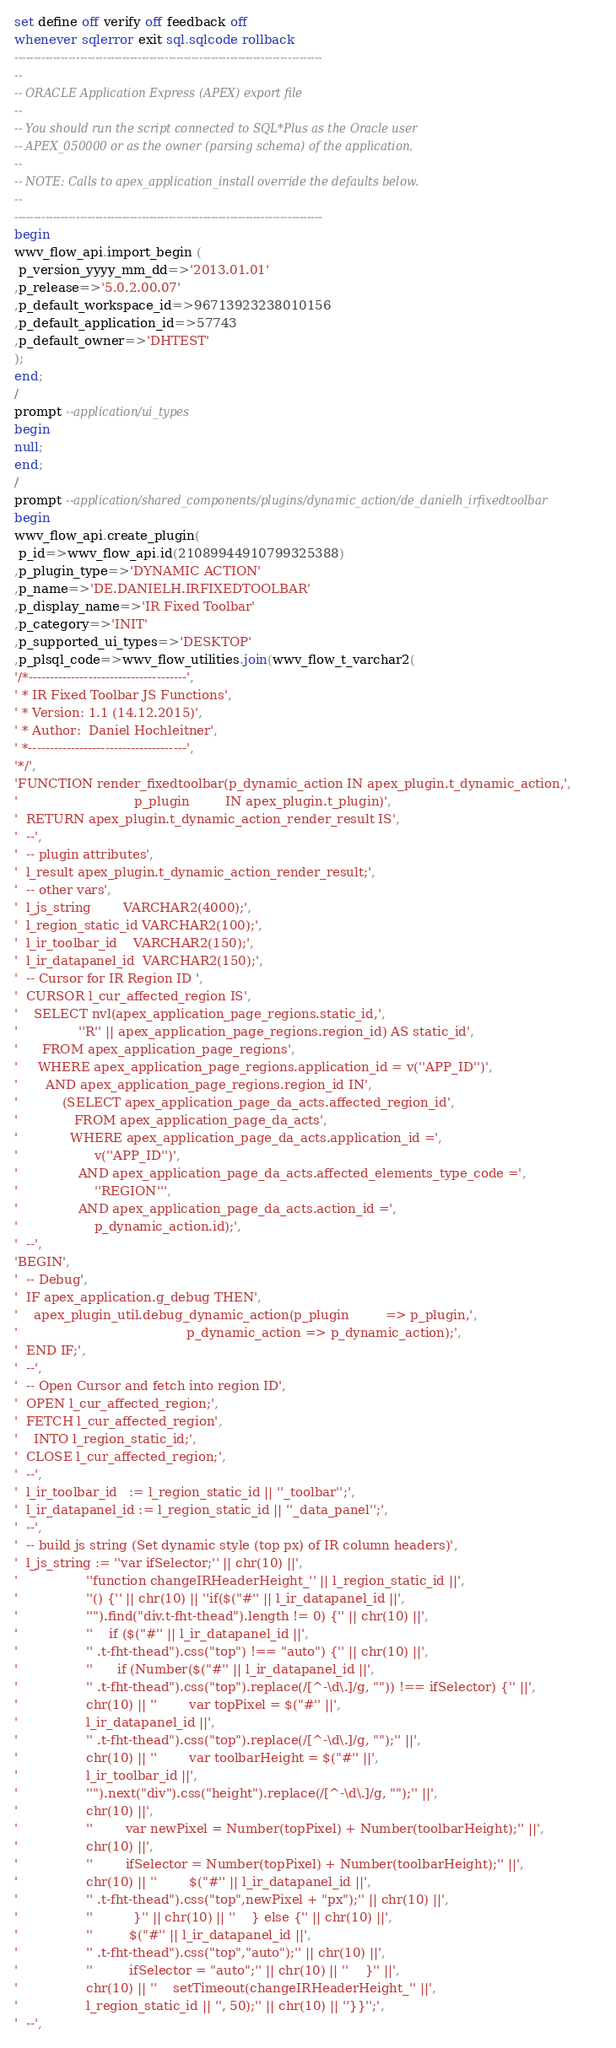<code> <loc_0><loc_0><loc_500><loc_500><_SQL_>set define off verify off feedback off
whenever sqlerror exit sql.sqlcode rollback
--------------------------------------------------------------------------------
--
-- ORACLE Application Express (APEX) export file
--
-- You should run the script connected to SQL*Plus as the Oracle user
-- APEX_050000 or as the owner (parsing schema) of the application.
--
-- NOTE: Calls to apex_application_install override the defaults below.
--
--------------------------------------------------------------------------------
begin
wwv_flow_api.import_begin (
 p_version_yyyy_mm_dd=>'2013.01.01'
,p_release=>'5.0.2.00.07'
,p_default_workspace_id=>96713923238010156
,p_default_application_id=>57743
,p_default_owner=>'DHTEST'
);
end;
/
prompt --application/ui_types
begin
null;
end;
/
prompt --application/shared_components/plugins/dynamic_action/de_danielh_irfixedtoolbar
begin
wwv_flow_api.create_plugin(
 p_id=>wwv_flow_api.id(21089944910799325388)
,p_plugin_type=>'DYNAMIC ACTION'
,p_name=>'DE.DANIELH.IRFIXEDTOOLBAR'
,p_display_name=>'IR Fixed Toolbar'
,p_category=>'INIT'
,p_supported_ui_types=>'DESKTOP'
,p_plsql_code=>wwv_flow_utilities.join(wwv_flow_t_varchar2(
'/*-------------------------------------',
' * IR Fixed Toolbar JS Functions',
' * Version: 1.1 (14.12.2015)',
' * Author:  Daniel Hochleitner',
' *-------------------------------------',
'*/',
'FUNCTION render_fixedtoolbar(p_dynamic_action IN apex_plugin.t_dynamic_action,',
'                             p_plugin         IN apex_plugin.t_plugin)',
'  RETURN apex_plugin.t_dynamic_action_render_result IS',
'  --',
'  -- plugin attributes',
'  l_result apex_plugin.t_dynamic_action_render_result;',
'  -- other vars',
'  l_js_string        VARCHAR2(4000);',
'  l_region_static_id VARCHAR2(100);',
'  l_ir_toolbar_id    VARCHAR2(150);',
'  l_ir_datapanel_id  VARCHAR2(150);',
'  -- Cursor for IR Region ID ',
'  CURSOR l_cur_affected_region IS',
'    SELECT nvl(apex_application_page_regions.static_id,',
'               ''R'' || apex_application_page_regions.region_id) AS static_id',
'      FROM apex_application_page_regions',
'     WHERE apex_application_page_regions.application_id = v(''APP_ID'')',
'       AND apex_application_page_regions.region_id IN',
'           (SELECT apex_application_page_da_acts.affected_region_id',
'              FROM apex_application_page_da_acts',
'             WHERE apex_application_page_da_acts.application_id =',
'                   v(''APP_ID'')',
'               AND apex_application_page_da_acts.affected_elements_type_code =',
'                   ''REGION''',
'               AND apex_application_page_da_acts.action_id =',
'                   p_dynamic_action.id);',
'  --',
'BEGIN',
'  -- Debug',
'  IF apex_application.g_debug THEN',
'    apex_plugin_util.debug_dynamic_action(p_plugin         => p_plugin,',
'                                          p_dynamic_action => p_dynamic_action);',
'  END IF;',
'  --',
'  -- Open Cursor and fetch into region ID',
'  OPEN l_cur_affected_region;',
'  FETCH l_cur_affected_region',
'    INTO l_region_static_id;',
'  CLOSE l_cur_affected_region;',
'  --',
'  l_ir_toolbar_id   := l_region_static_id || ''_toolbar'';',
'  l_ir_datapanel_id := l_region_static_id || ''_data_panel'';',
'  --',
'  -- build js string (Set dynamic style (top px) of IR column headers)',
'  l_js_string := ''var ifSelector;'' || chr(10) ||',
'                 ''function changeIRHeaderHeight_'' || l_region_static_id ||',
'                 ''() {'' || chr(10) || ''if($("#'' || l_ir_datapanel_id ||',
'                 ''").find("div.t-fht-thead").length != 0) {'' || chr(10) ||',
'                 ''    if ($("#'' || l_ir_datapanel_id ||',
'                 '' .t-fht-thead").css("top") !== "auto") {'' || chr(10) ||',
'                 ''      if (Number($("#'' || l_ir_datapanel_id ||',
'                 '' .t-fht-thead").css("top").replace(/[^-\d\.]/g, "")) !== ifSelector) {'' ||',
'                 chr(10) || ''        var topPixel = $("#'' ||',
'                 l_ir_datapanel_id ||',
'                 '' .t-fht-thead").css("top").replace(/[^-\d\.]/g, "");'' ||',
'                 chr(10) || ''        var toolbarHeight = $("#'' ||',
'                 l_ir_toolbar_id ||',
'                 ''").next("div").css("height").replace(/[^-\d\.]/g, "");'' ||',
'                 chr(10) ||',
'                 ''        var newPixel = Number(topPixel) + Number(toolbarHeight);'' ||',
'                 chr(10) ||',
'                 ''        ifSelector = Number(topPixel) + Number(toolbarHeight);'' ||',
'                 chr(10) || ''        $("#'' || l_ir_datapanel_id ||',
'                 '' .t-fht-thead").css("top",newPixel + "px");'' || chr(10) ||',
'                 ''          }'' || chr(10) || ''    } else {'' || chr(10) ||',
'                 ''         $("#'' || l_ir_datapanel_id ||',
'                 '' .t-fht-thead").css("top","auto");'' || chr(10) ||',
'                 ''         ifSelector = "auto";'' || chr(10) || ''    }'' ||',
'                 chr(10) || ''    setTimeout(changeIRHeaderHeight_'' ||',
'                 l_region_static_id || '', 50);'' || chr(10) || ''}}'';',
'  --',</code> 